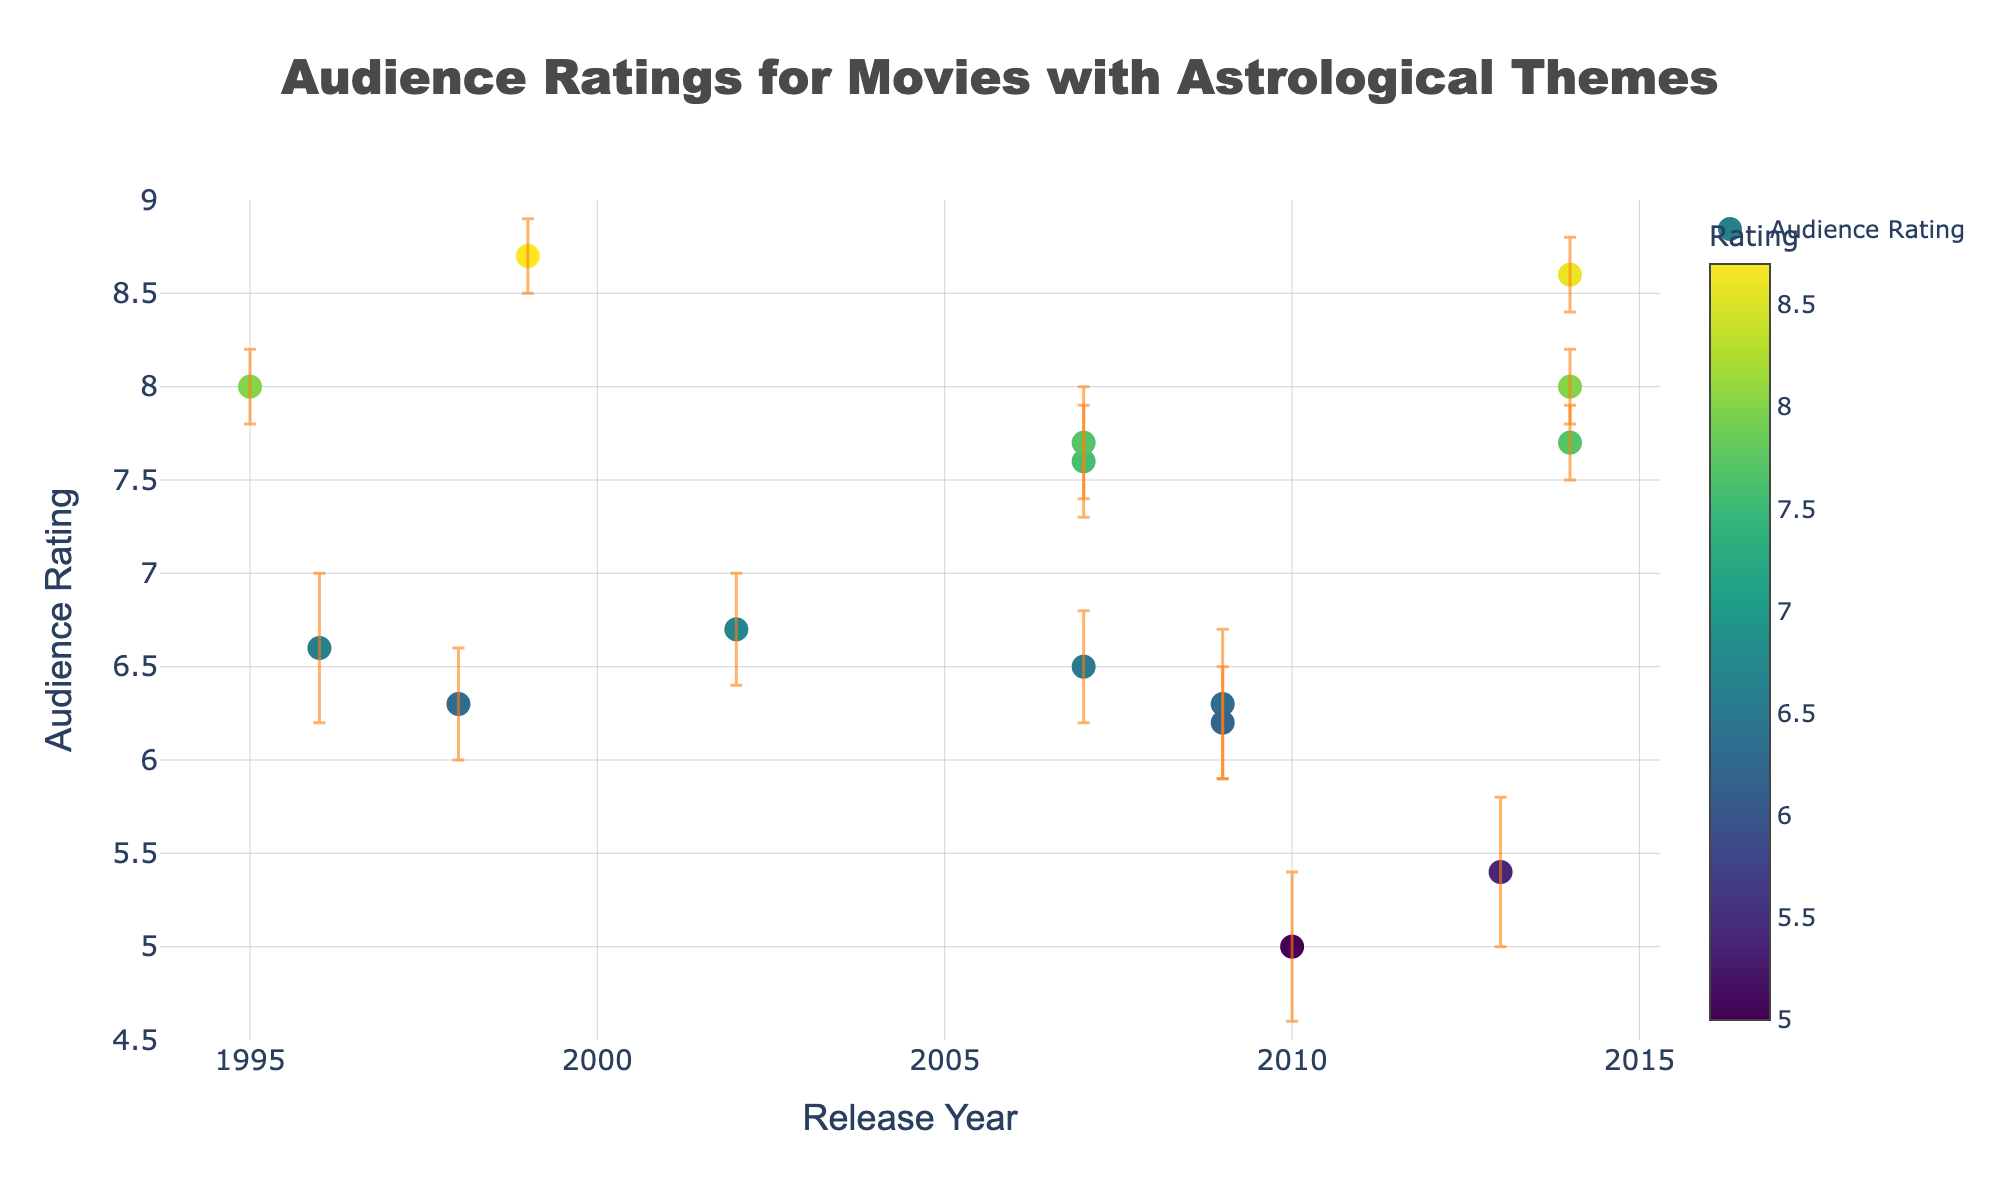what is the title of the figure? The title is located at the top of the figure and describes the main focus. In this case, it states, "Audience Ratings for Movies with Astrological Themes."
Answer: Audience Ratings for Movies with Astrological Themes how many movies were released in 2014? There are three data points on the x-axis labeled 2014, each representing a movie released in that year.
Answer: 3 which movie has the highest audience rating? The data point with the highest y-value represents the highest audience rating. "The Matrix" has the highest rating, as indicated by the data point at 8.7.
Answer: The Matrix what is the range of audience ratings? The y-axis shows the audience ratings from 4.5 to 9. The calculations indicate that the range is from the lowest rating, 5.0 for "Sci-Fi High: The Movie Musical," to the highest rating, 8.7 for "The Matrix."
Answer: 5.0 to 8.7 which movie has the widest confidence interval? By comparing the error bars' lengths, "Astrology of Fate" has the widest interval, indicated by the largest difference between the lower (5.0) and upper (5.8) bounds, resulting in an interval width of 0.8.
Answer: Astrology of Fate how did audience ratings for movies released in 2009 compare? We compare the ratings for movies released in 2009: "Knowing" (6.2) and "Astro Boy" (6.3). Both scored similarly, less significant than higher-rated movies.
Answer: similar, both in the 6-range what is the average audience rating for movies released between 2010-2014? Compute the average of movies released between 2010 and 2014: "Sci-Fi High: The Movie Musical" (5.0), "Astrology of Fate" (5.4), "Interstellar" (8.6), "Guardians of the Galaxy" (8.0), and "The Fault in Our Stars" (7.7). Sum: 34.7, Average: 34.7/5 = 6.94.
Answer: 6.94 which year had the highest average audience rating for its movies? Calculate the average ratings for each year. 2014 has movies "Interstellar" (8.6), "Guardians of the Galaxy" (8.0), and "The Fault in Our Stars" (7.7). Sum: 24.3, Average: 24.3/3 = 8.1, the highest among the years.
Answer: 2014 what is the confidence interval for "Stardust"? Refer to the error bars for "Stardust." The lower bound is 7.3 and the upper bound is 7.9. The confidence interval is (7.3, 7.9).
Answer: (7.3, 7.9) do any movies have an audience rating of exactly 6.5? By examining the y-values, "The Nines" has an audience rating of exactly 6.5.
Answer: The Nines 